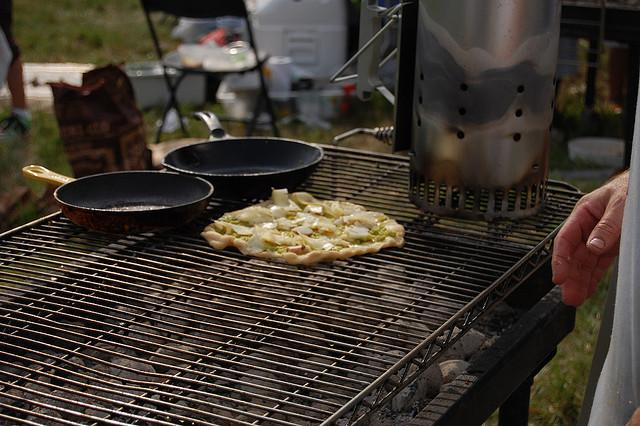Where is the item being grilled normally prepared?

Choices:
A) grill
B) griddle
C) sauce pot
D) oven oven 